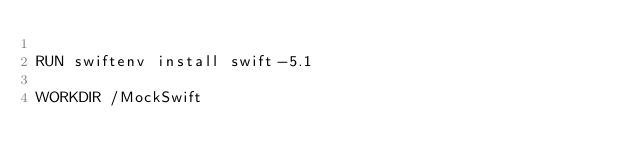<code> <loc_0><loc_0><loc_500><loc_500><_Dockerfile_>
RUN swiftenv install swift-5.1

WORKDIR /MockSwift
</code> 